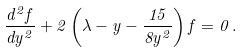Convert formula to latex. <formula><loc_0><loc_0><loc_500><loc_500>\frac { d ^ { 2 } f } { d y ^ { 2 } } + 2 \left ( \lambda - y - \frac { 1 5 } { 8 y ^ { 2 } } \right ) f = 0 \, .</formula> 